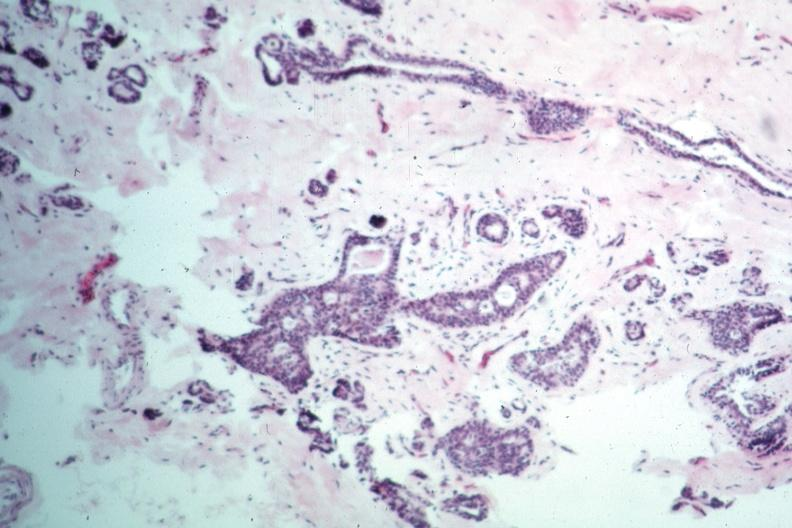what appears benign?
Answer the question using a single word or phrase. This typical lesion 